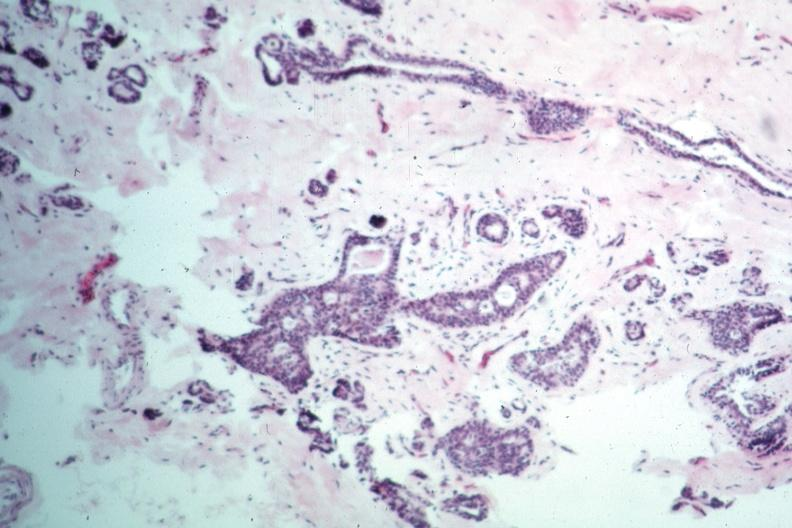what appears benign?
Answer the question using a single word or phrase. This typical lesion 